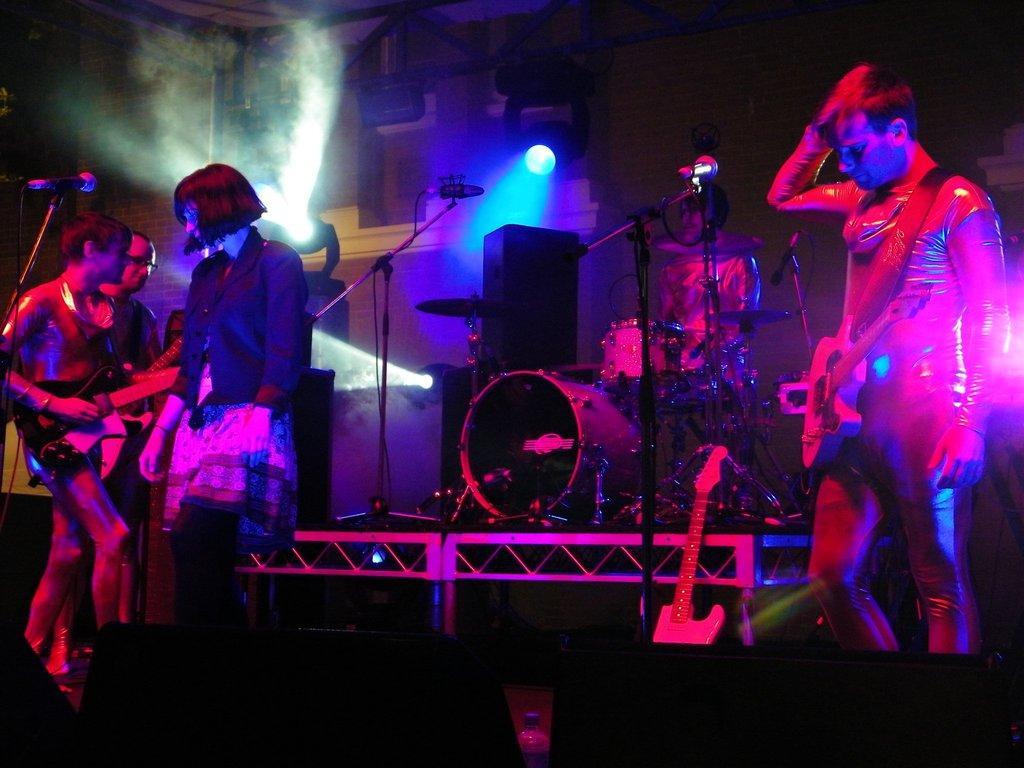Describe this image in one or two sentences. In the picture we can see three people are standing with musical instruments and playing it and one woman standing near them and in the background, we can see a man playing an orchestra and near to him we some microphones with a stand and to the wall we can see some focus lights. 